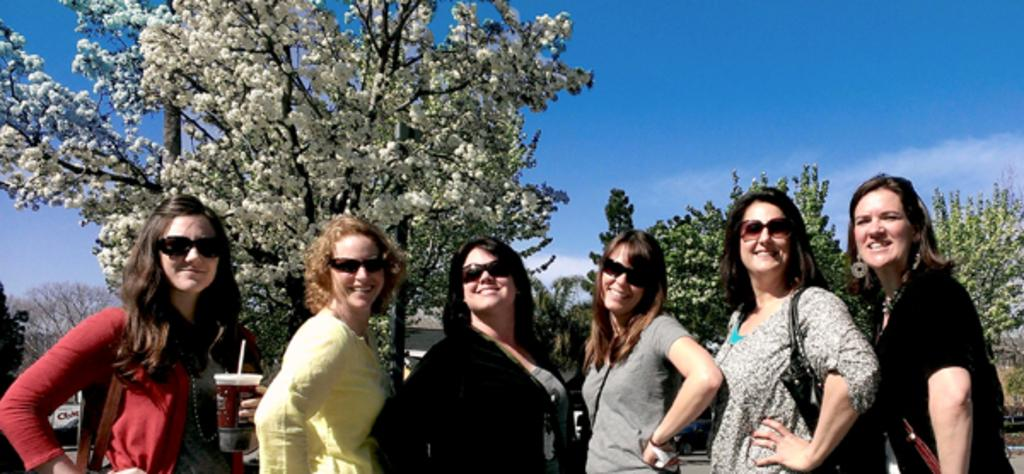How many people are in the image? There is a group of people standing in the image. What is the person on the left holding? The person on the left is holding a glass. What can be seen in the background of the image? There are trees with white and green colors, and the sky with white and blue colors in the background of the image. What type of lip can be seen on the person on the right in the image? There is no lip visible on the person on the right in the image. What color are the socks worn by the person in the middle of the group? There is no information about socks or the person in the middle of the group in the provided facts. 